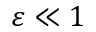Convert formula to latex. <formula><loc_0><loc_0><loc_500><loc_500>\varepsilon \ll 1</formula> 